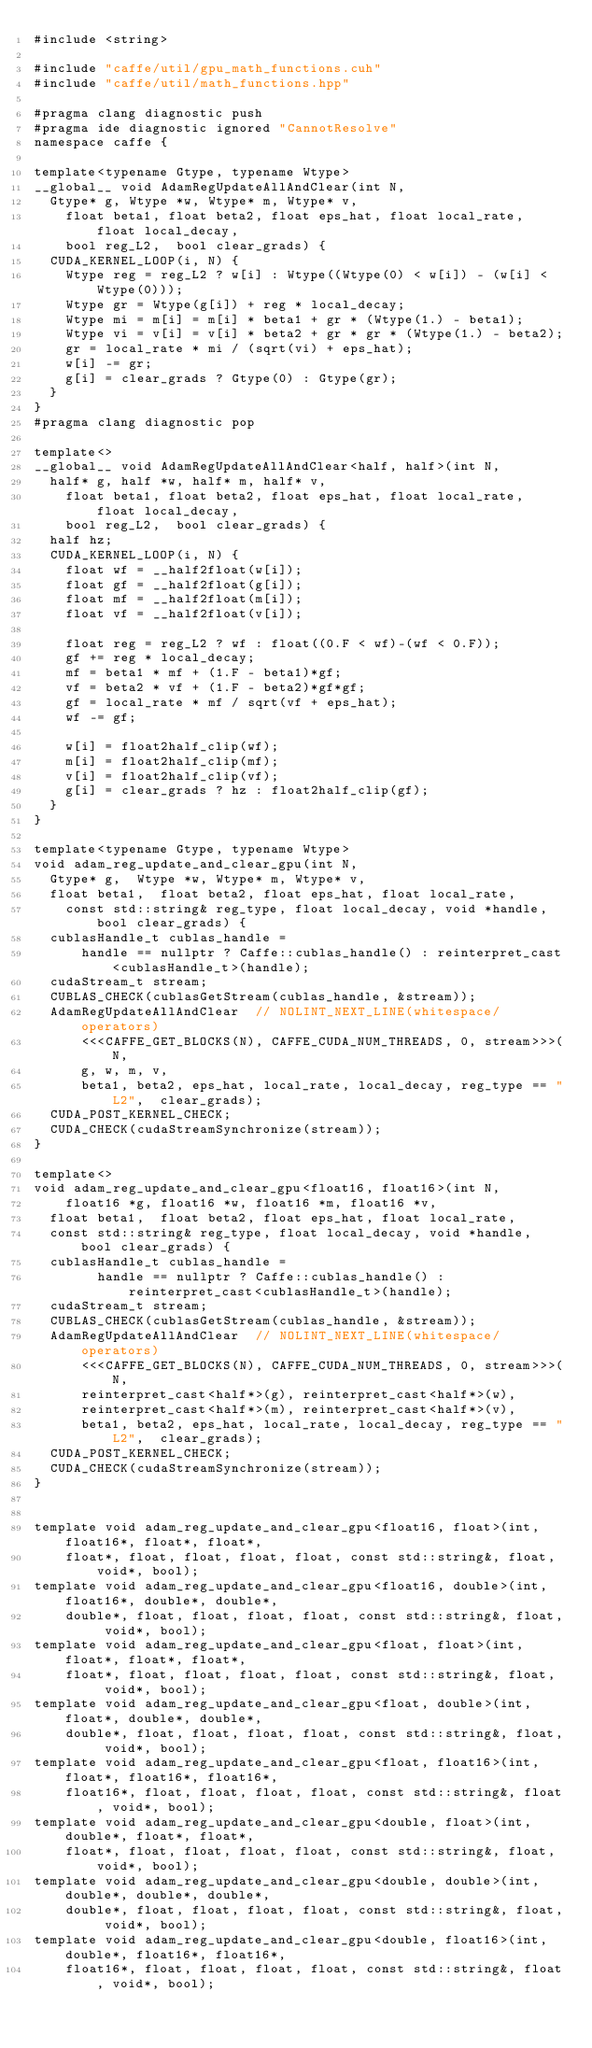Convert code to text. <code><loc_0><loc_0><loc_500><loc_500><_Cuda_>#include <string>

#include "caffe/util/gpu_math_functions.cuh"
#include "caffe/util/math_functions.hpp"

#pragma clang diagnostic push
#pragma ide diagnostic ignored "CannotResolve"
namespace caffe {

template<typename Gtype, typename Wtype>
__global__ void AdamRegUpdateAllAndClear(int N,
  Gtype* g, Wtype *w, Wtype* m, Wtype* v,
    float beta1, float beta2, float eps_hat, float local_rate,  float local_decay,
    bool reg_L2,  bool clear_grads) {
  CUDA_KERNEL_LOOP(i, N) {
    Wtype reg = reg_L2 ? w[i] : Wtype((Wtype(0) < w[i]) - (w[i] < Wtype(0)));
    Wtype gr = Wtype(g[i]) + reg * local_decay;
    Wtype mi = m[i] = m[i] * beta1 + gr * (Wtype(1.) - beta1);
    Wtype vi = v[i] = v[i] * beta2 + gr * gr * (Wtype(1.) - beta2);
    gr = local_rate * mi / (sqrt(vi) + eps_hat);
    w[i] -= gr;
    g[i] = clear_grads ? Gtype(0) : Gtype(gr);
  }
}
#pragma clang diagnostic pop

template<>
__global__ void AdamRegUpdateAllAndClear<half, half>(int N,
  half* g, half *w, half* m, half* v,
    float beta1, float beta2, float eps_hat, float local_rate, float local_decay,
    bool reg_L2,  bool clear_grads) {
  half hz;
  CUDA_KERNEL_LOOP(i, N) {
    float wf = __half2float(w[i]);
    float gf = __half2float(g[i]);
    float mf = __half2float(m[i]);
    float vf = __half2float(v[i]);

    float reg = reg_L2 ? wf : float((0.F < wf)-(wf < 0.F));
    gf += reg * local_decay;
    mf = beta1 * mf + (1.F - beta1)*gf;
    vf = beta2 * vf + (1.F - beta2)*gf*gf;
    gf = local_rate * mf / sqrt(vf + eps_hat);
    wf -= gf;

    w[i] = float2half_clip(wf);
    m[i] = float2half_clip(mf);
    v[i] = float2half_clip(vf);
    g[i] = clear_grads ? hz : float2half_clip(gf);
  }
}

template<typename Gtype, typename Wtype>
void adam_reg_update_and_clear_gpu(int N,
  Gtype* g,  Wtype *w, Wtype* m, Wtype* v,
  float beta1,  float beta2, float eps_hat, float local_rate,
    const std::string& reg_type, float local_decay, void *handle, bool clear_grads) {
  cublasHandle_t cublas_handle =
      handle == nullptr ? Caffe::cublas_handle() : reinterpret_cast<cublasHandle_t>(handle);
  cudaStream_t stream;
  CUBLAS_CHECK(cublasGetStream(cublas_handle, &stream));
  AdamRegUpdateAllAndClear  // NOLINT_NEXT_LINE(whitespace/operators)
      <<<CAFFE_GET_BLOCKS(N), CAFFE_CUDA_NUM_THREADS, 0, stream>>>(N,
      g, w, m, v,
      beta1, beta2, eps_hat, local_rate, local_decay, reg_type == "L2",  clear_grads);
  CUDA_POST_KERNEL_CHECK;
  CUDA_CHECK(cudaStreamSynchronize(stream));
}

template<>
void adam_reg_update_and_clear_gpu<float16, float16>(int N,
    float16 *g, float16 *w, float16 *m, float16 *v,
  float beta1,  float beta2, float eps_hat, float local_rate,
  const std::string& reg_type, float local_decay, void *handle, bool clear_grads) {
  cublasHandle_t cublas_handle =
        handle == nullptr ? Caffe::cublas_handle() : reinterpret_cast<cublasHandle_t>(handle);
  cudaStream_t stream;
  CUBLAS_CHECK(cublasGetStream(cublas_handle, &stream));
  AdamRegUpdateAllAndClear  // NOLINT_NEXT_LINE(whitespace/operators)
      <<<CAFFE_GET_BLOCKS(N), CAFFE_CUDA_NUM_THREADS, 0, stream>>>(N,
      reinterpret_cast<half*>(g), reinterpret_cast<half*>(w),
      reinterpret_cast<half*>(m), reinterpret_cast<half*>(v),
      beta1, beta2, eps_hat, local_rate, local_decay, reg_type == "L2",  clear_grads);
  CUDA_POST_KERNEL_CHECK;
  CUDA_CHECK(cudaStreamSynchronize(stream));
}


template void adam_reg_update_and_clear_gpu<float16, float>(int, float16*, float*, float*,
    float*, float, float, float, float, const std::string&, float, void*, bool);
template void adam_reg_update_and_clear_gpu<float16, double>(int, float16*, double*, double*,
    double*, float, float, float, float, const std::string&, float, void*, bool);
template void adam_reg_update_and_clear_gpu<float, float>(int, float*, float*, float*,
    float*, float, float, float, float, const std::string&, float,  void*, bool);
template void adam_reg_update_and_clear_gpu<float, double>(int, float*, double*, double*,
    double*, float, float, float, float, const std::string&, float, void*, bool);
template void adam_reg_update_and_clear_gpu<float, float16>(int, float*, float16*, float16*,
    float16*, float, float, float, float, const std::string&, float, void*, bool);
template void adam_reg_update_and_clear_gpu<double, float>(int, double*, float*, float*,
    float*, float, float, float, float, const std::string&, float, void*, bool);
template void adam_reg_update_and_clear_gpu<double, double>(int, double*, double*, double*,
    double*, float, float, float, float, const std::string&, float, void*, bool);
template void adam_reg_update_and_clear_gpu<double, float16>(int, double*, float16*, float16*,
    float16*, float, float, float, float, const std::string&, float, void*, bool);</code> 